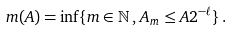Convert formula to latex. <formula><loc_0><loc_0><loc_500><loc_500>m ( A ) = \inf \{ m \in \mathbb { N } \, , \, A _ { m } \leq A 2 ^ { - \ell } \} \, .</formula> 